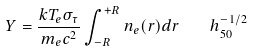Convert formula to latex. <formula><loc_0><loc_0><loc_500><loc_500>Y = \frac { k T _ { e } \sigma _ { \tau } } { m _ { e } c ^ { 2 } } \int ^ { + R } _ { - R } n _ { e } ( r ) d r \quad h _ { 5 0 } ^ { - 1 / 2 }</formula> 